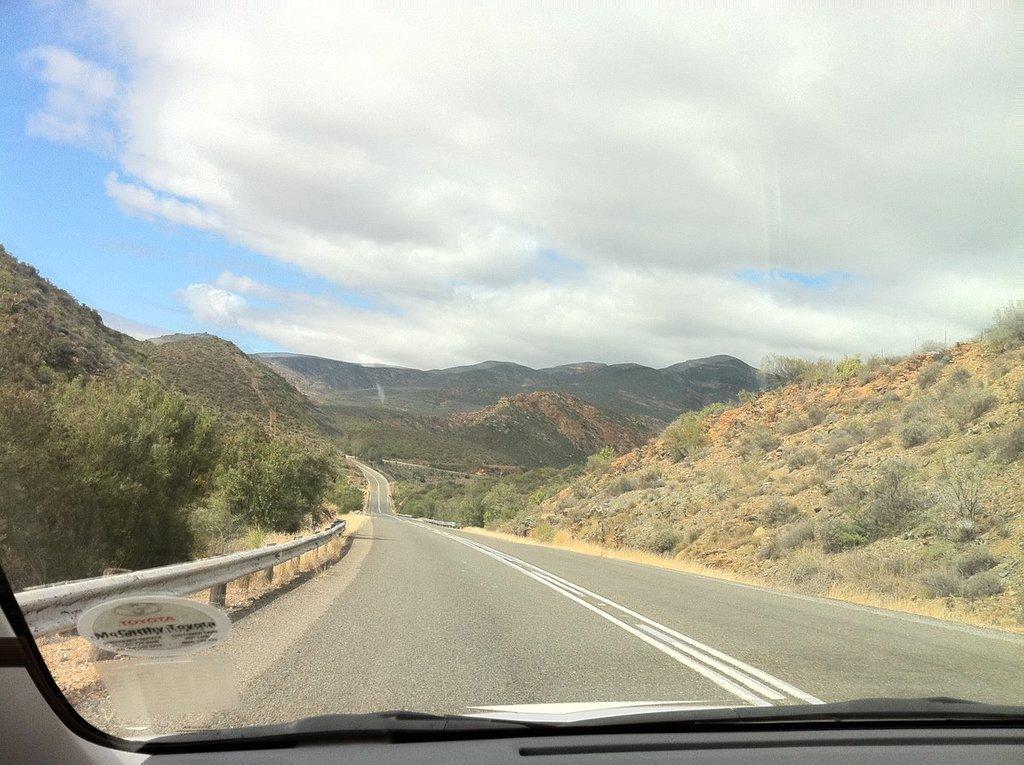Can you describe this image briefly? In this image in the background there are mountains. On the right side there are trees. On the right side there are trees and there are dry plants and the sky is cloudy. 